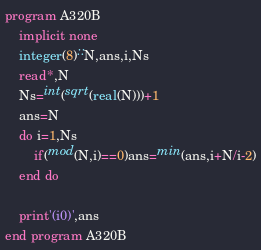<code> <loc_0><loc_0><loc_500><loc_500><_FORTRAN_>program A320B
    implicit none
    integer(8)::N,ans,i,Ns
    read*,N
    Ns=int(sqrt(real(N)))+1
    ans=N
    do i=1,Ns
        if(mod(N,i)==0)ans=min(ans,i+N/i-2)
    end do

    print'(i0)',ans
end program A320B</code> 